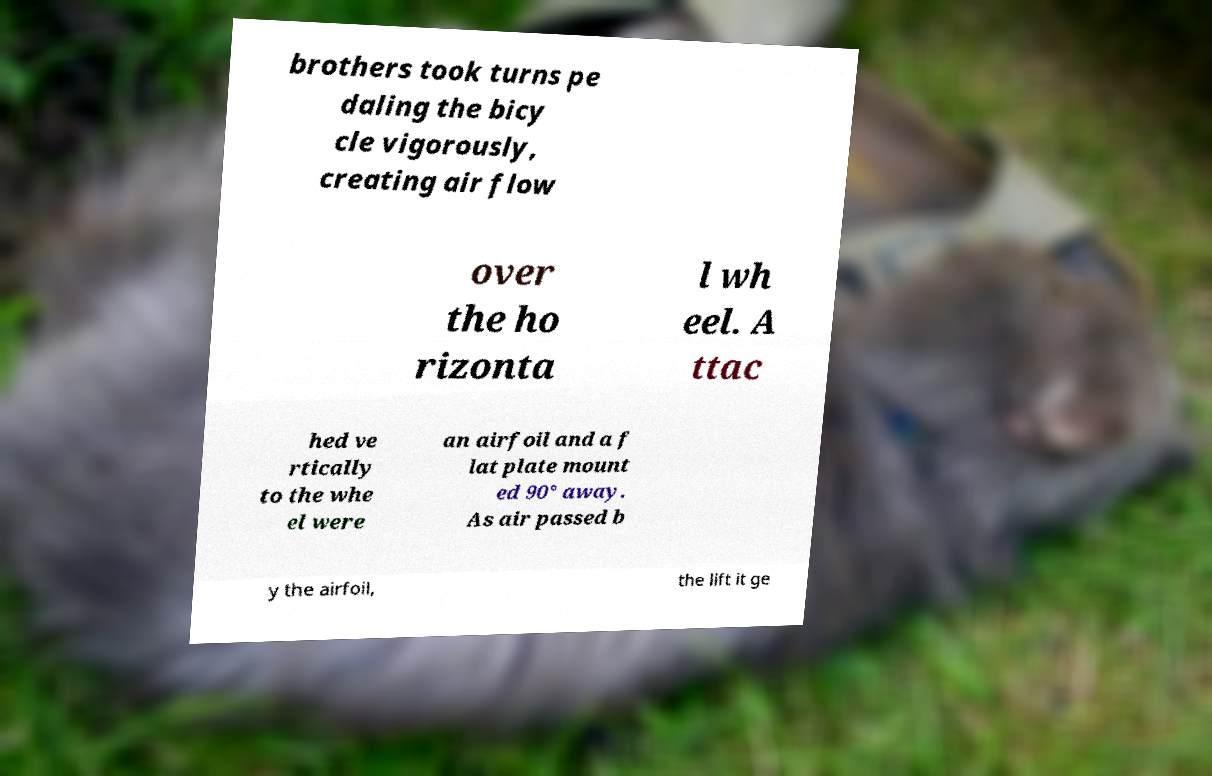For documentation purposes, I need the text within this image transcribed. Could you provide that? brothers took turns pe daling the bicy cle vigorously, creating air flow over the ho rizonta l wh eel. A ttac hed ve rtically to the whe el were an airfoil and a f lat plate mount ed 90° away. As air passed b y the airfoil, the lift it ge 